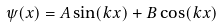<formula> <loc_0><loc_0><loc_500><loc_500>\psi ( x ) = A \sin ( k x ) + B \cos ( k x )</formula> 